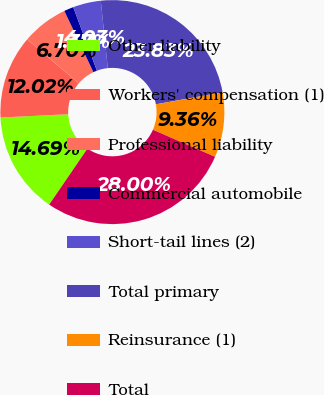<chart> <loc_0><loc_0><loc_500><loc_500><pie_chart><fcel>Other liability<fcel>Workers' compensation (1)<fcel>Professional liability<fcel>Commercial automobile<fcel>Short-tail lines (2)<fcel>Total primary<fcel>Reinsurance (1)<fcel>Total<nl><fcel>14.69%<fcel>12.02%<fcel>6.7%<fcel>1.37%<fcel>4.03%<fcel>23.83%<fcel>9.36%<fcel>28.0%<nl></chart> 